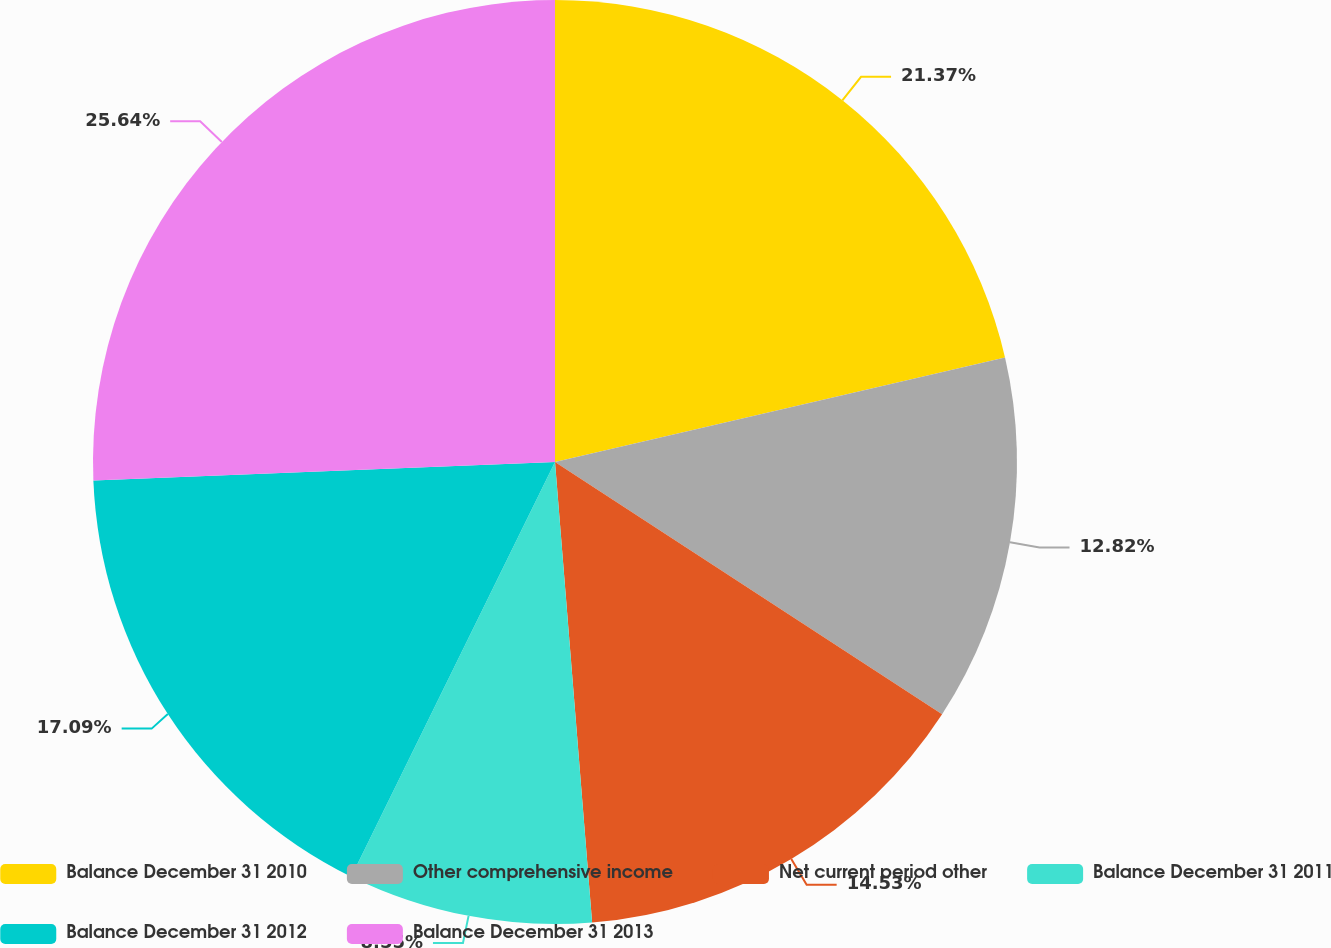<chart> <loc_0><loc_0><loc_500><loc_500><pie_chart><fcel>Balance December 31 2010<fcel>Other comprehensive income<fcel>Net current period other<fcel>Balance December 31 2011<fcel>Balance December 31 2012<fcel>Balance December 31 2013<nl><fcel>21.37%<fcel>12.82%<fcel>14.53%<fcel>8.55%<fcel>17.09%<fcel>25.64%<nl></chart> 